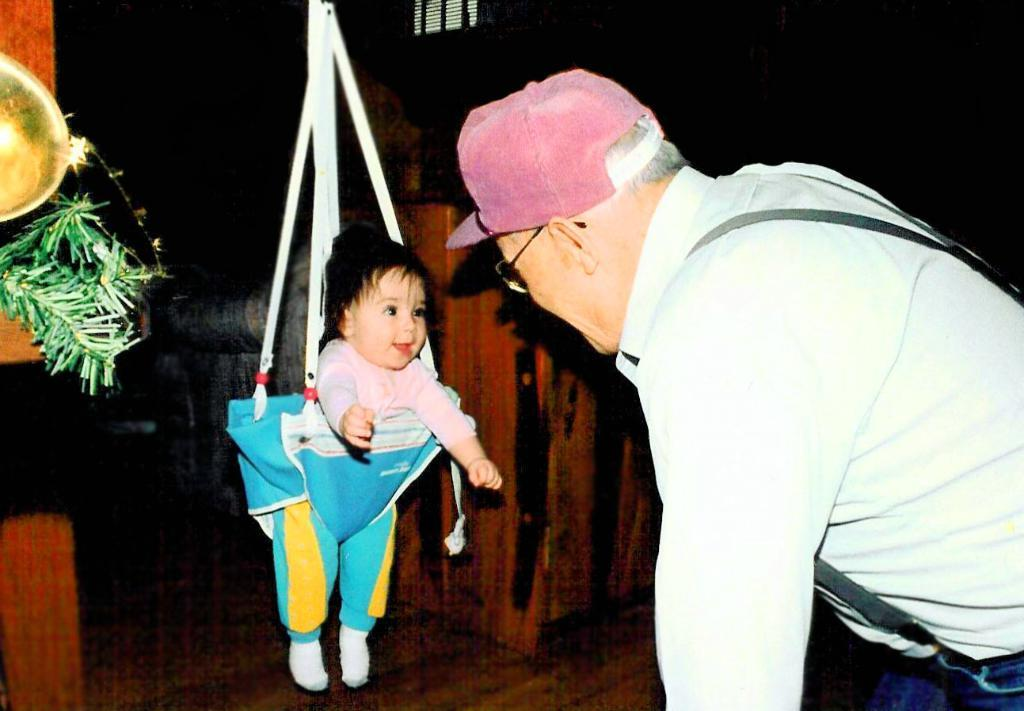Who is present in the image? There is a man in the image. Where is the man located in the image? The man is standing at the right side of the image. What is the man wearing in the image? The man is wearing a white shirt and suspenders. What else can be seen in the image besides the man? There is a baby in the image. How is the baby positioned in the image? The baby is in a bouncer swing. What is the effect of the peace treaty on the children in the image? There is no mention of a peace treaty or children in the image, so it is not possible to determine its effect on them. 